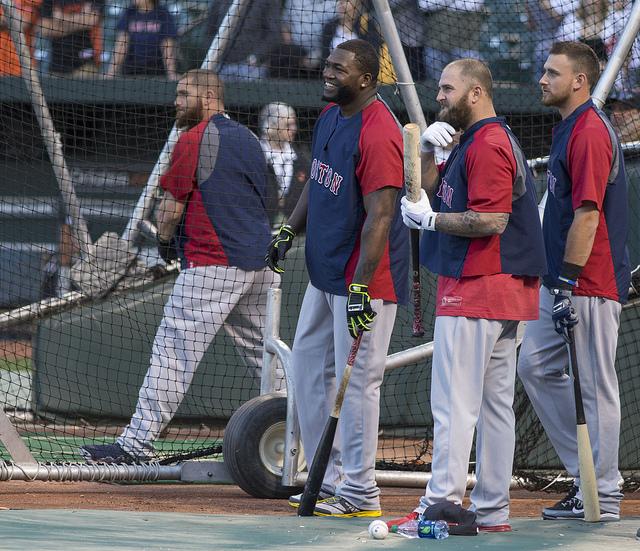Is this a major league team?
Keep it brief. Yes. How many people are in the stands?
Concise answer only. 30. Are these players in the middle of a game?
Keep it brief. No. What color are the uniforms?
Be succinct. Red and blue. Why are the players wearing gloves?
Concise answer only. Batting. Where are the baseball players in the photograph?
Be succinct. Stadium. What letter is written on the player's shirt?
Write a very short answer. Boston. What team are these players playing for?
Be succinct. Boston. Is everyone wearing a jersey?
Write a very short answer. Yes. How many people are shown in the picture?
Keep it brief. 5. What sport is being played?
Answer briefly. Baseball. 